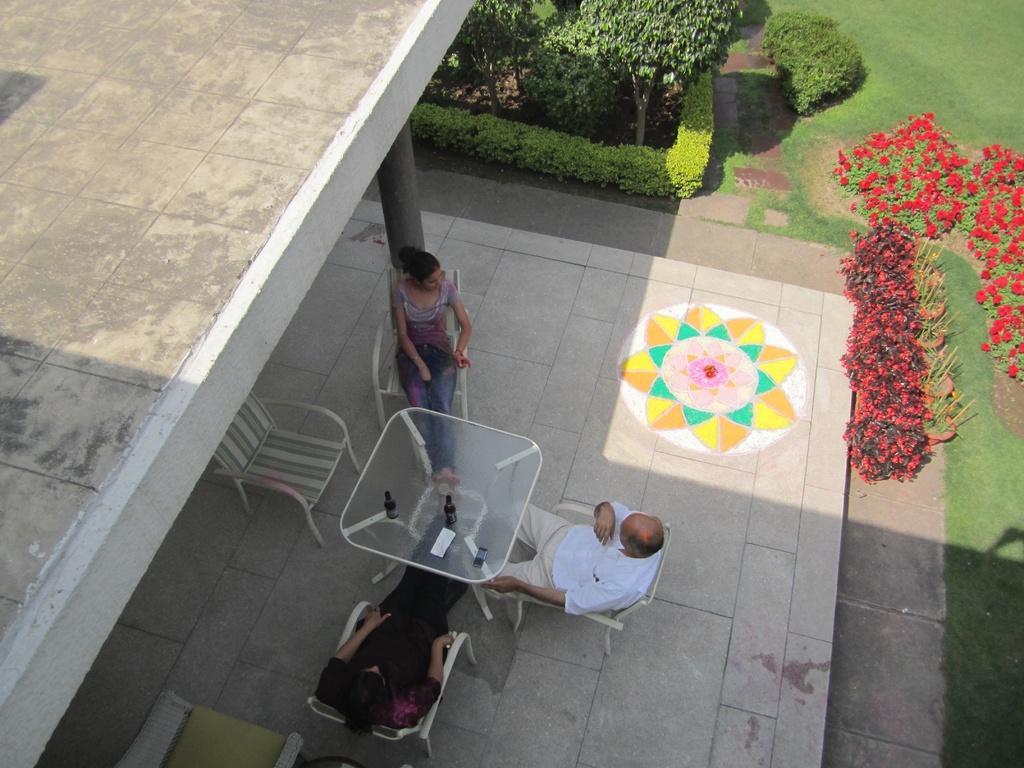Please provide a concise description of this image. This picture shows two people seated on the chairs and we see bottles on the table and we see a woman seated on the other side and we see couple of trees and flower plants and we see a building 